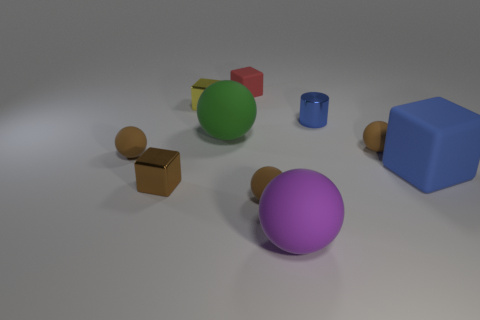There is a shiny thing that is the same color as the large matte cube; what size is it?
Offer a terse response. Small. Does the tiny metallic cylinder have the same color as the big rubber cube?
Ensure brevity in your answer.  Yes. What material is the big blue object that is the same shape as the small yellow thing?
Offer a terse response. Rubber. Is the red block made of the same material as the big purple ball?
Offer a terse response. Yes. What is the color of the cube on the right side of the brown rubber object in front of the large blue matte thing?
Your answer should be compact. Blue. The cylinder that is made of the same material as the small yellow cube is what size?
Give a very brief answer. Small. How many large green metal things are the same shape as the purple thing?
Offer a very short reply. 0. What number of objects are brown objects that are to the right of the small yellow object or objects behind the tiny blue cylinder?
Offer a terse response. 4. There is a brown rubber object that is in front of the large block; what number of matte objects are on the right side of it?
Keep it short and to the point. 3. Is the shape of the thing that is behind the small yellow object the same as the metal object in front of the large green thing?
Your answer should be compact. Yes. 